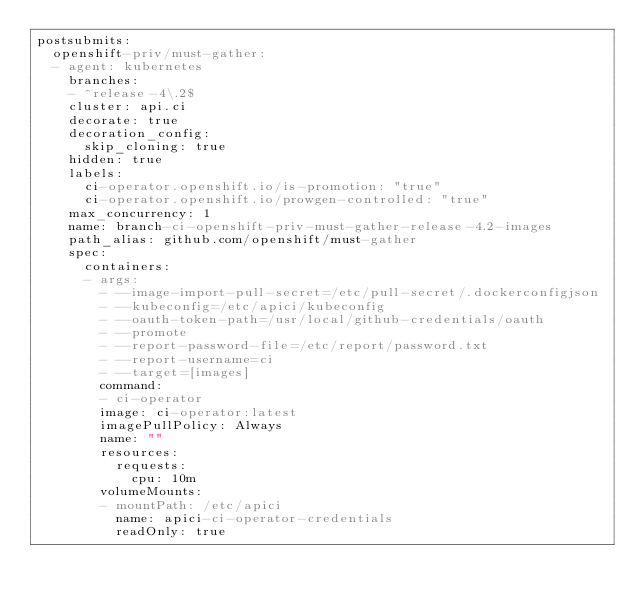Convert code to text. <code><loc_0><loc_0><loc_500><loc_500><_YAML_>postsubmits:
  openshift-priv/must-gather:
  - agent: kubernetes
    branches:
    - ^release-4\.2$
    cluster: api.ci
    decorate: true
    decoration_config:
      skip_cloning: true
    hidden: true
    labels:
      ci-operator.openshift.io/is-promotion: "true"
      ci-operator.openshift.io/prowgen-controlled: "true"
    max_concurrency: 1
    name: branch-ci-openshift-priv-must-gather-release-4.2-images
    path_alias: github.com/openshift/must-gather
    spec:
      containers:
      - args:
        - --image-import-pull-secret=/etc/pull-secret/.dockerconfigjson
        - --kubeconfig=/etc/apici/kubeconfig
        - --oauth-token-path=/usr/local/github-credentials/oauth
        - --promote
        - --report-password-file=/etc/report/password.txt
        - --report-username=ci
        - --target=[images]
        command:
        - ci-operator
        image: ci-operator:latest
        imagePullPolicy: Always
        name: ""
        resources:
          requests:
            cpu: 10m
        volumeMounts:
        - mountPath: /etc/apici
          name: apici-ci-operator-credentials
          readOnly: true</code> 